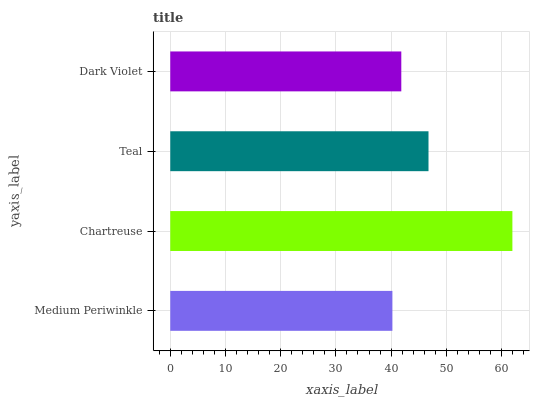Is Medium Periwinkle the minimum?
Answer yes or no. Yes. Is Chartreuse the maximum?
Answer yes or no. Yes. Is Teal the minimum?
Answer yes or no. No. Is Teal the maximum?
Answer yes or no. No. Is Chartreuse greater than Teal?
Answer yes or no. Yes. Is Teal less than Chartreuse?
Answer yes or no. Yes. Is Teal greater than Chartreuse?
Answer yes or no. No. Is Chartreuse less than Teal?
Answer yes or no. No. Is Teal the high median?
Answer yes or no. Yes. Is Dark Violet the low median?
Answer yes or no. Yes. Is Chartreuse the high median?
Answer yes or no. No. Is Medium Periwinkle the low median?
Answer yes or no. No. 